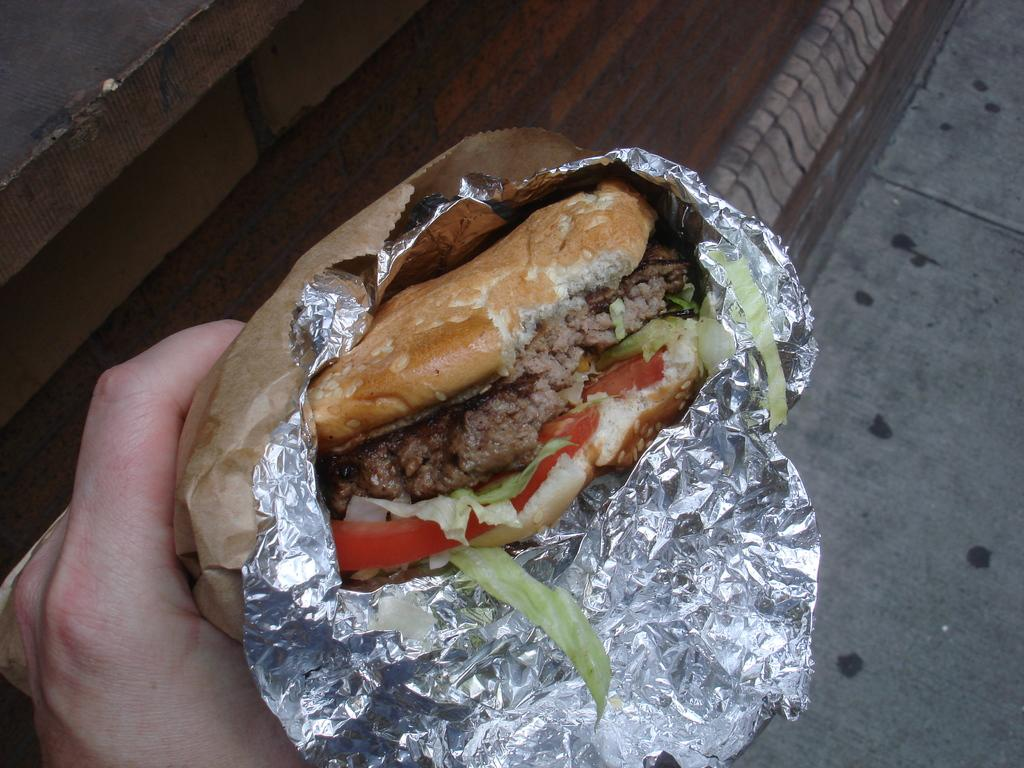What is the person's hand holding in the image? There is a person's hand holding a burger in the image. What can be seen at the bottom of the image? There is a road at the bottom of the image. What type of thread is being used to sew the pocket on the trees in the image? There are no trees or pockets present in the image, so there is no thread being used for sewing. 